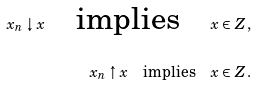<formula> <loc_0><loc_0><loc_500><loc_500>x _ { n } \downarrow x \quad \text {implies} \quad x \in Z \, , \\ x _ { n } \uparrow x \quad \text {implies} \quad x \in Z \, .</formula> 